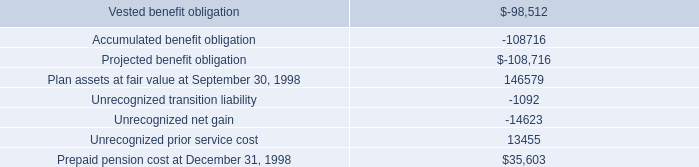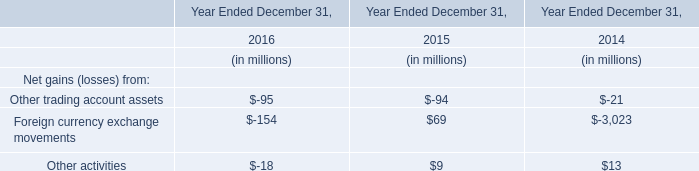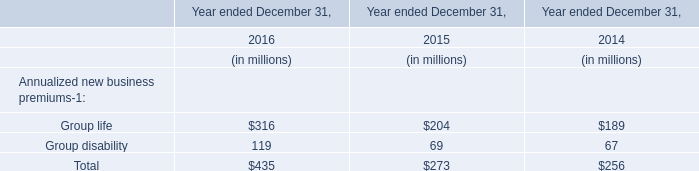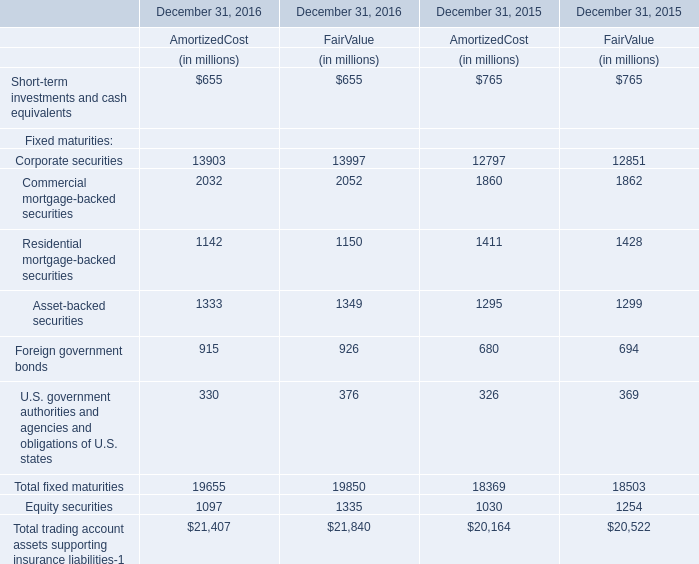Does the proportion of Residential mortgage-backed securities in total larger than that of Asset-backed securities in 2016 for amortized cost ? 
Computations: ((1142 / 19655) - (1333 / 19655))
Answer: -0.00972. 